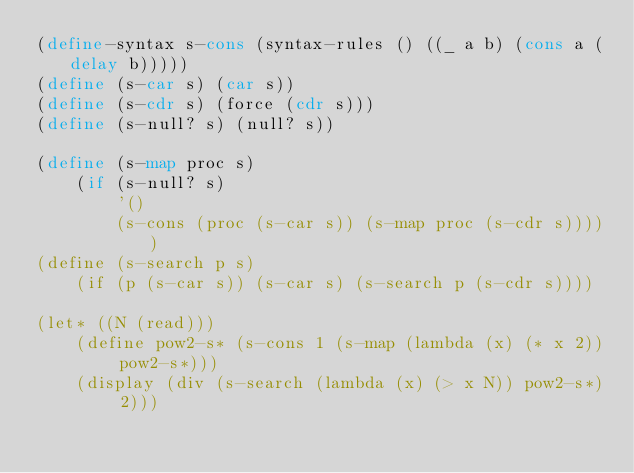Convert code to text. <code><loc_0><loc_0><loc_500><loc_500><_Scheme_>(define-syntax s-cons (syntax-rules () ((_ a b) (cons a (delay b)))))
(define (s-car s) (car s))
(define (s-cdr s) (force (cdr s)))
(define (s-null? s) (null? s))

(define (s-map proc s)
    (if (s-null? s)
        '()
        (s-cons (proc (s-car s)) (s-map proc (s-cdr s)))))
(define (s-search p s)
    (if (p (s-car s)) (s-car s) (s-search p (s-cdr s))))

(let* ((N (read)))
    (define pow2-s* (s-cons 1 (s-map (lambda (x) (* x 2)) pow2-s*)))
    (display (div (s-search (lambda (x) (> x N)) pow2-s*) 2)))</code> 